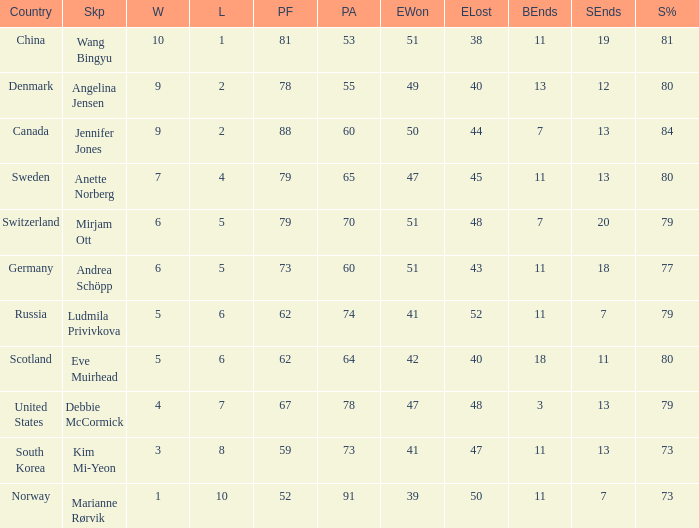When the country was Scotland, how many ends were won? 1.0. 